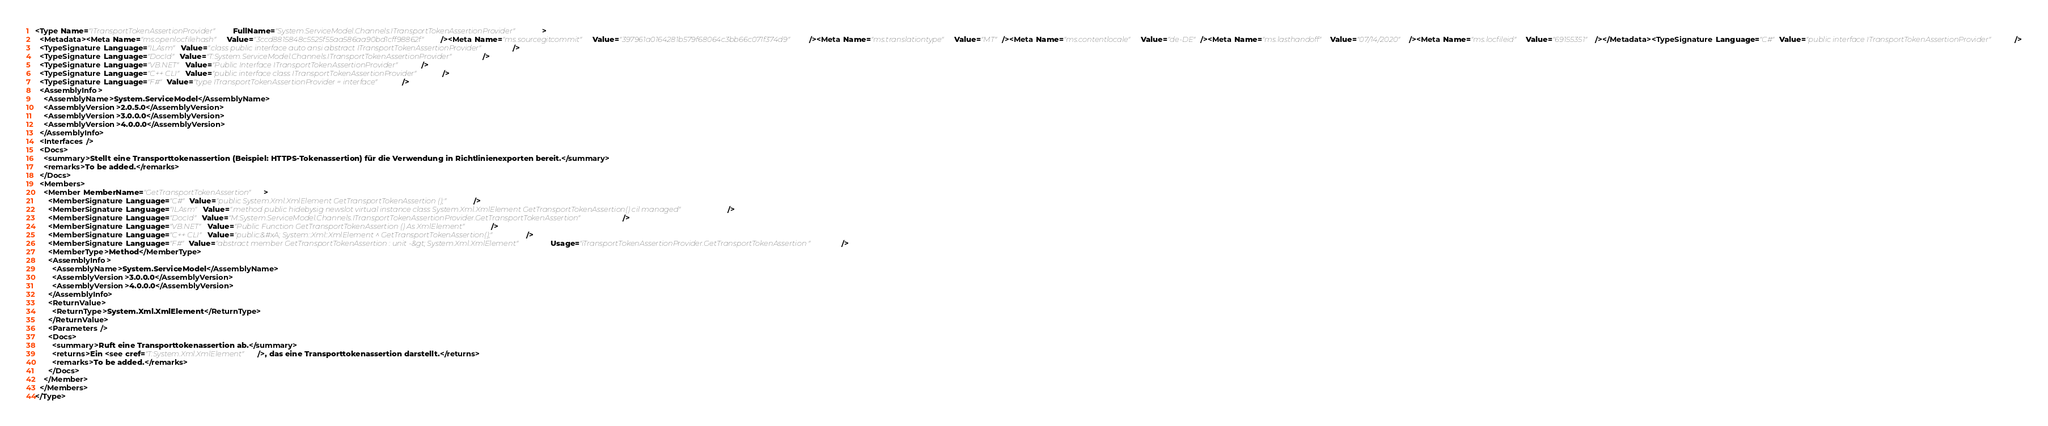Convert code to text. <code><loc_0><loc_0><loc_500><loc_500><_XML_><Type Name="ITransportTokenAssertionProvider" FullName="System.ServiceModel.Channels.ITransportTokenAssertionProvider">
  <Metadata><Meta Name="ms.openlocfilehash" Value="3ccd8815848c5525f55aa586aa90bd1cff98862f" /><Meta Name="ms.sourcegitcommit" Value="397961a0164281b579f68064c3bb66c071f374d9" /><Meta Name="ms.translationtype" Value="MT" /><Meta Name="ms.contentlocale" Value="de-DE" /><Meta Name="ms.lasthandoff" Value="07/14/2020" /><Meta Name="ms.locfileid" Value="69155351" /></Metadata><TypeSignature Language="C#" Value="public interface ITransportTokenAssertionProvider" />
  <TypeSignature Language="ILAsm" Value=".class public interface auto ansi abstract ITransportTokenAssertionProvider" />
  <TypeSignature Language="DocId" Value="T:System.ServiceModel.Channels.ITransportTokenAssertionProvider" />
  <TypeSignature Language="VB.NET" Value="Public Interface ITransportTokenAssertionProvider" />
  <TypeSignature Language="C++ CLI" Value="public interface class ITransportTokenAssertionProvider" />
  <TypeSignature Language="F#" Value="type ITransportTokenAssertionProvider = interface" />
  <AssemblyInfo>
    <AssemblyName>System.ServiceModel</AssemblyName>
    <AssemblyVersion>2.0.5.0</AssemblyVersion>
    <AssemblyVersion>3.0.0.0</AssemblyVersion>
    <AssemblyVersion>4.0.0.0</AssemblyVersion>
  </AssemblyInfo>
  <Interfaces />
  <Docs>
    <summary>Stellt eine Transporttokenassertion (Beispiel: HTTPS-Tokenassertion) für die Verwendung in Richtlinienexporten bereit.</summary>
    <remarks>To be added.</remarks>
  </Docs>
  <Members>
    <Member MemberName="GetTransportTokenAssertion">
      <MemberSignature Language="C#" Value="public System.Xml.XmlElement GetTransportTokenAssertion ();" />
      <MemberSignature Language="ILAsm" Value=".method public hidebysig newslot virtual instance class System.Xml.XmlElement GetTransportTokenAssertion() cil managed" />
      <MemberSignature Language="DocId" Value="M:System.ServiceModel.Channels.ITransportTokenAssertionProvider.GetTransportTokenAssertion" />
      <MemberSignature Language="VB.NET" Value="Public Function GetTransportTokenAssertion () As XmlElement" />
      <MemberSignature Language="C++ CLI" Value="public:&#xA; System::Xml::XmlElement ^ GetTransportTokenAssertion();" />
      <MemberSignature Language="F#" Value="abstract member GetTransportTokenAssertion : unit -&gt; System.Xml.XmlElement" Usage="iTransportTokenAssertionProvider.GetTransportTokenAssertion " />
      <MemberType>Method</MemberType>
      <AssemblyInfo>
        <AssemblyName>System.ServiceModel</AssemblyName>
        <AssemblyVersion>3.0.0.0</AssemblyVersion>
        <AssemblyVersion>4.0.0.0</AssemblyVersion>
      </AssemblyInfo>
      <ReturnValue>
        <ReturnType>System.Xml.XmlElement</ReturnType>
      </ReturnValue>
      <Parameters />
      <Docs>
        <summary>Ruft eine Transporttokenassertion ab.</summary>
        <returns>Ein <see cref="T:System.Xml.XmlElement" />, das eine Transporttokenassertion darstellt.</returns>
        <remarks>To be added.</remarks>
      </Docs>
    </Member>
  </Members>
</Type>
</code> 